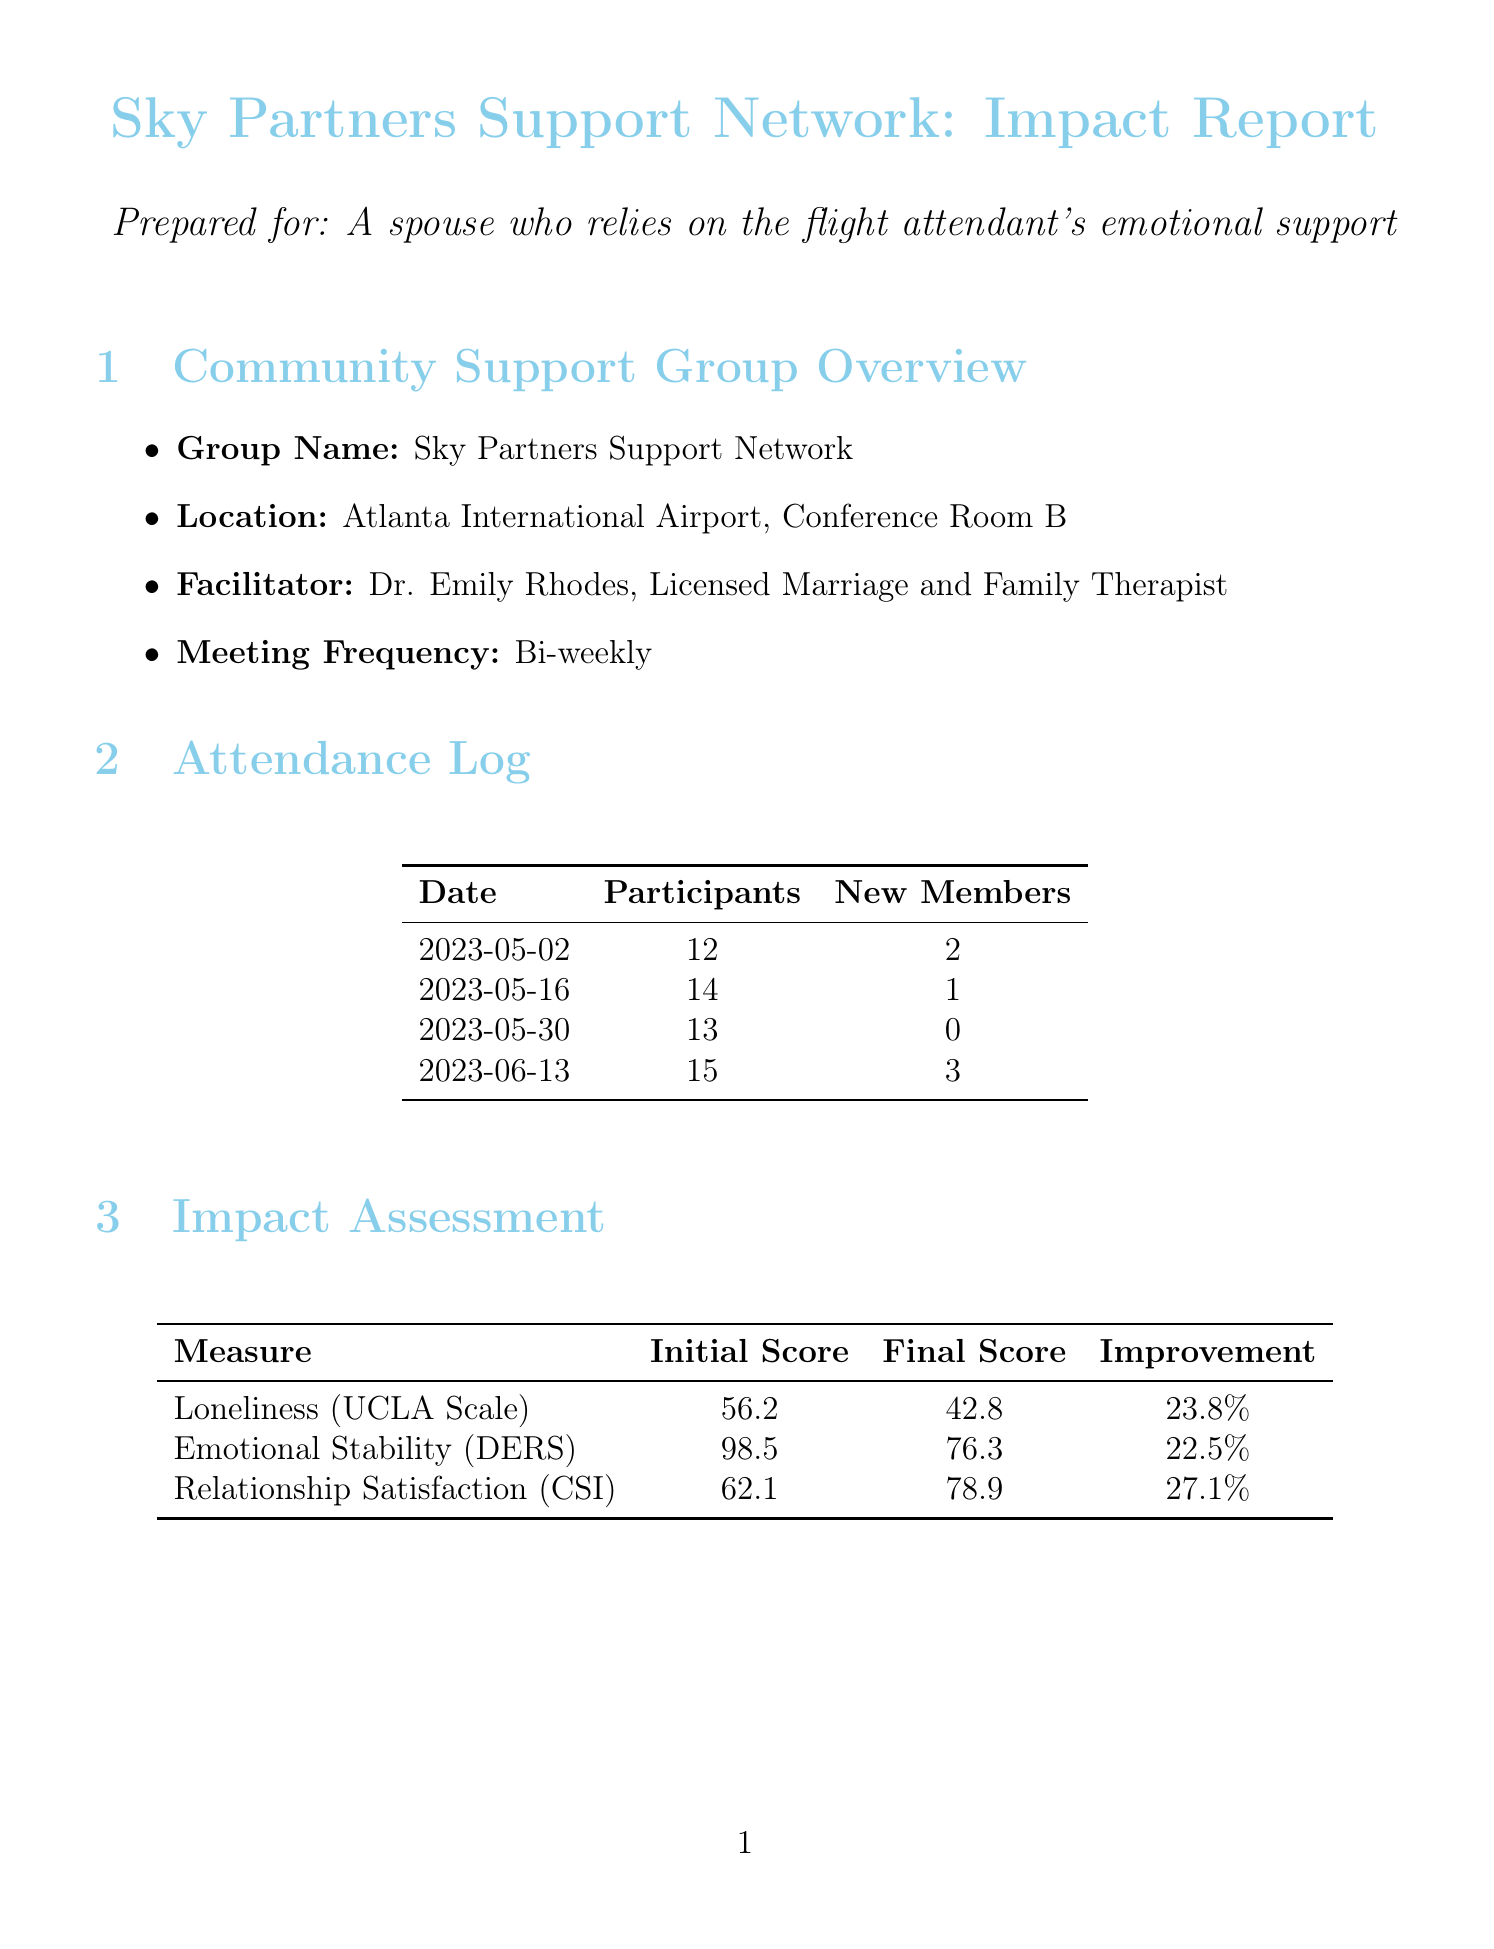What is the name of the community support group? The name of the community support group is mentioned in the document as "Sky Partners Support Network".
Answer: Sky Partners Support Network Who is the facilitator of the group? The document specifies that Dr. Emily Rhodes is the facilitator of the group.
Answer: Dr. Emily Rhodes How often does the group meet? The frequency of meetings is stated in the document as "Bi-weekly".
Answer: Bi-weekly What was the initial average loneliness score? The document provides the initial average loneliness score as 56.2 based on the UCLA Loneliness Scale.
Answer: 56.2 How many participants attended the meeting on June 13, 2023? The attendance log indicates that there were 15 participants on that date.
Answer: 15 What percentage improvement was observed in emotional stability? The document details the improvement percentage in emotional stability as 22.5%.
Answer: 22.5% What type of activity is mentioned for anxiety reduction? The document lists "Guided meditation for anxiety reduction" as one of the group activities.
Answer: Guided meditation for anxiety reduction Which organization provides informational resources and referrals? The document states that the "Association of Flight Attendants-CWA" provides such resources.
Answer: Association of Flight Attendants-CWA What future initiative involves pairing couples? The document mentions the launch of a mentorship program pairing experienced couples with newcomers.
Answer: Mentorship program pairing experienced couples with newcomers 